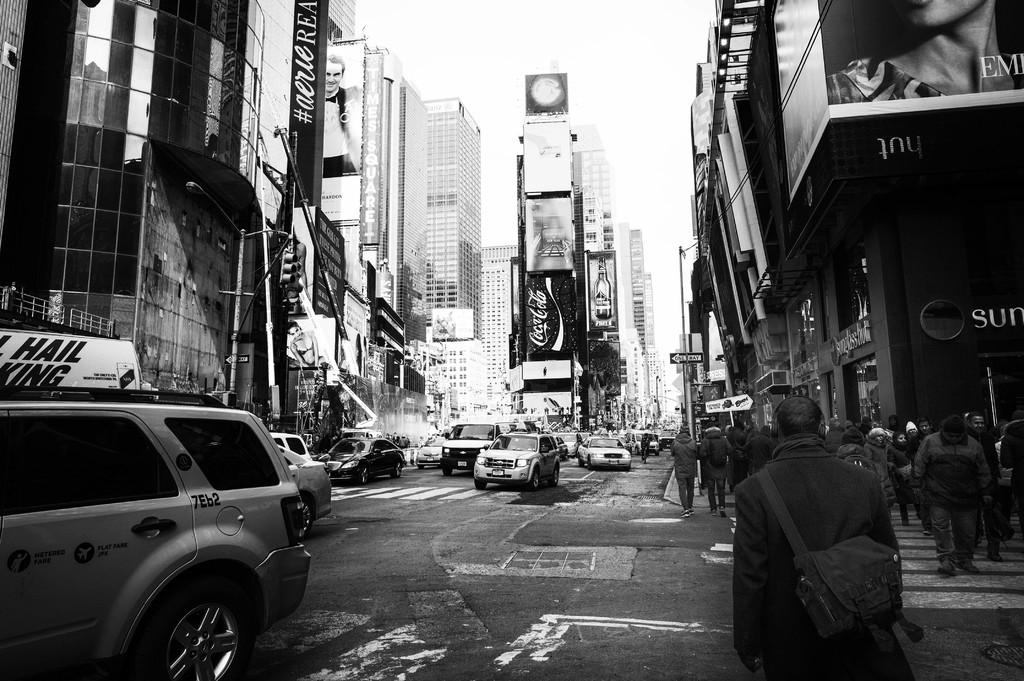What are the people in the image doing? The people in the image are walking. What else can be seen on the road besides people? Cars are visible on the road. What type of signage is present in the image? There are boards and hoardings in the image. What structures are visible in the image? Poles and buildings are visible in the image. What is visible in the background of the image? The sky is visible in the background of the image. Can you describe the thickness of the fog in the image? There is no fog present in the image; the sky is visible in the background. What type of boundary is depicted in the image? There is no boundary depicted in the image; the focus is on people walking, cars on the road, and various signage and structures. 